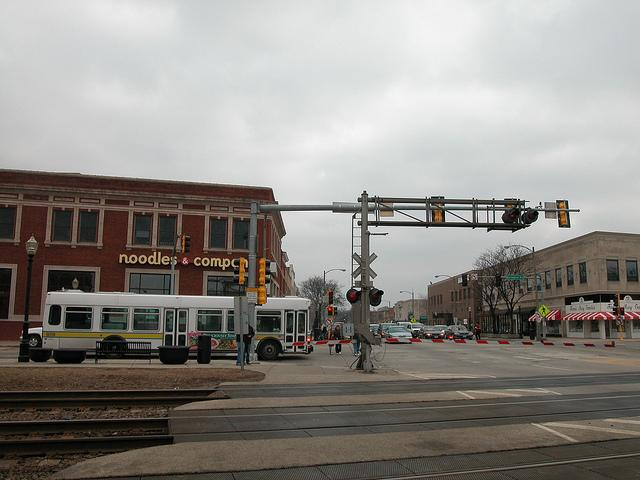What is causing traffic to stop? train 